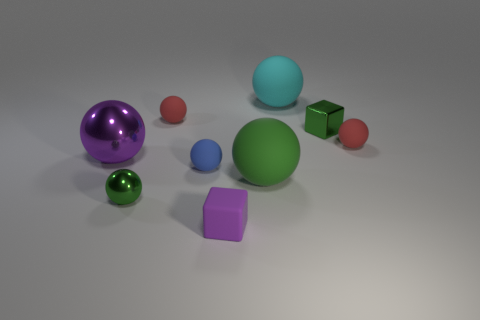Do the objects in this image suggest any specific theme or concept? The array of geometric shapes in different colors could represent diversity and variety. The arrangement is simplistic yet intriguing, possibly suggesting concepts of order, mathematical properties, or a study in form and color. There's also an element of playfulness, reminiscent of children's blocks or a simple physics simulation that could evoke thoughts about education and learning. 